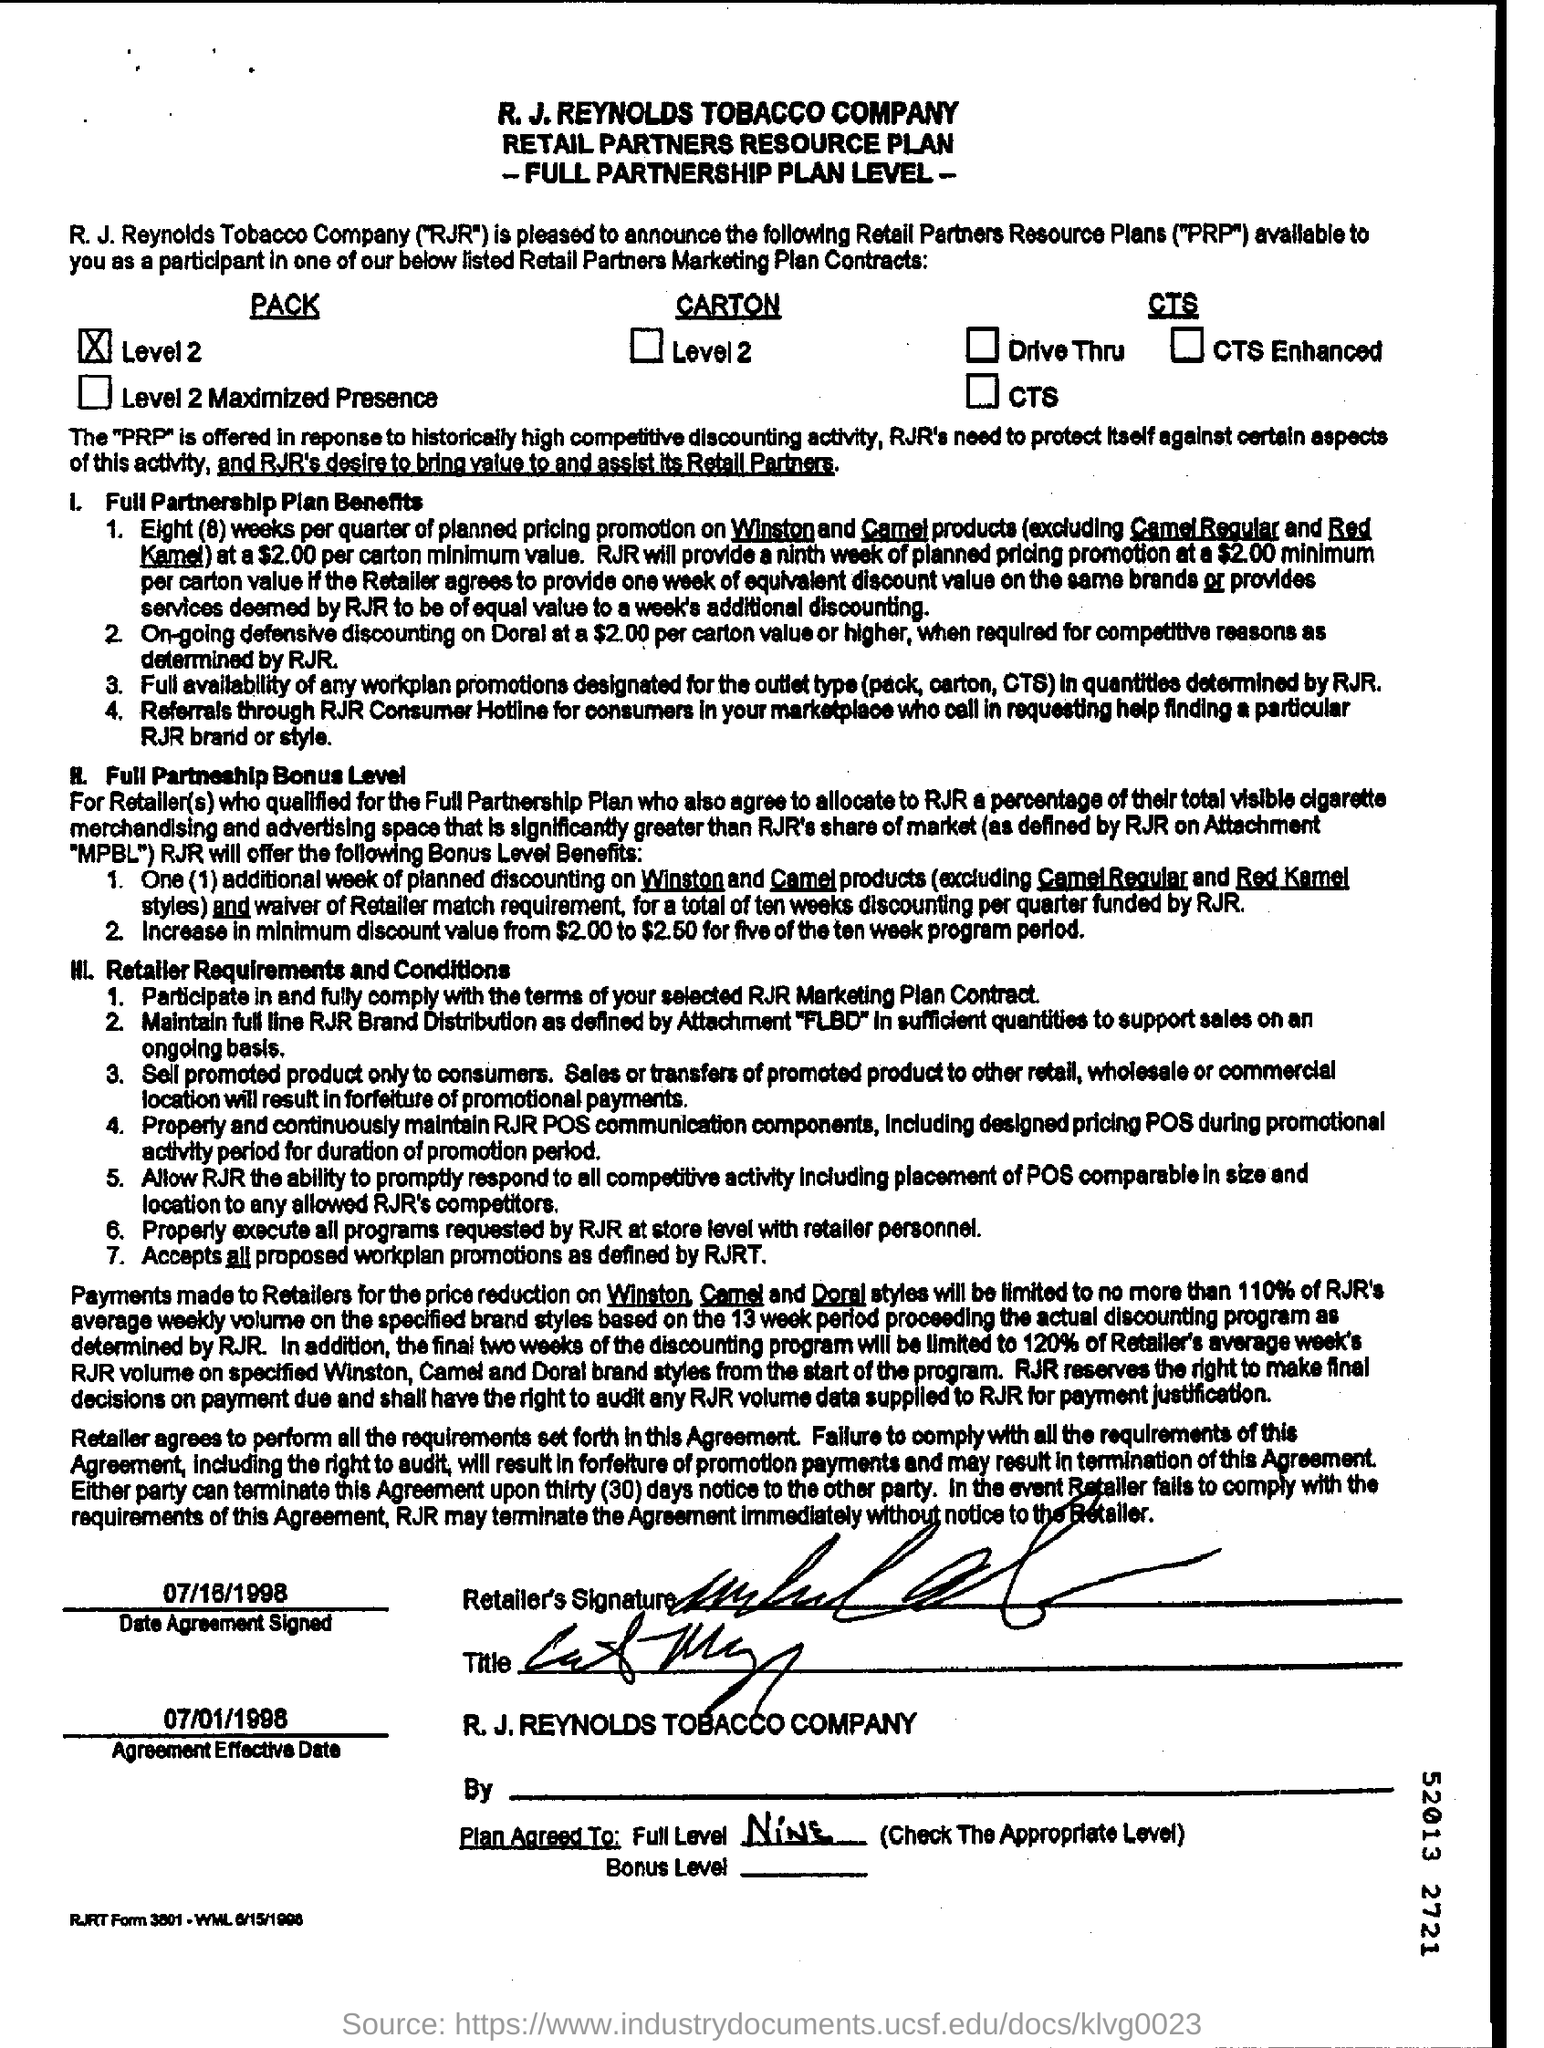Specify some key components in this picture. The first title in the document is "R.J.Reynolds Tobacco Company.. The second title in this document is "Retail Partners Resource plan. 